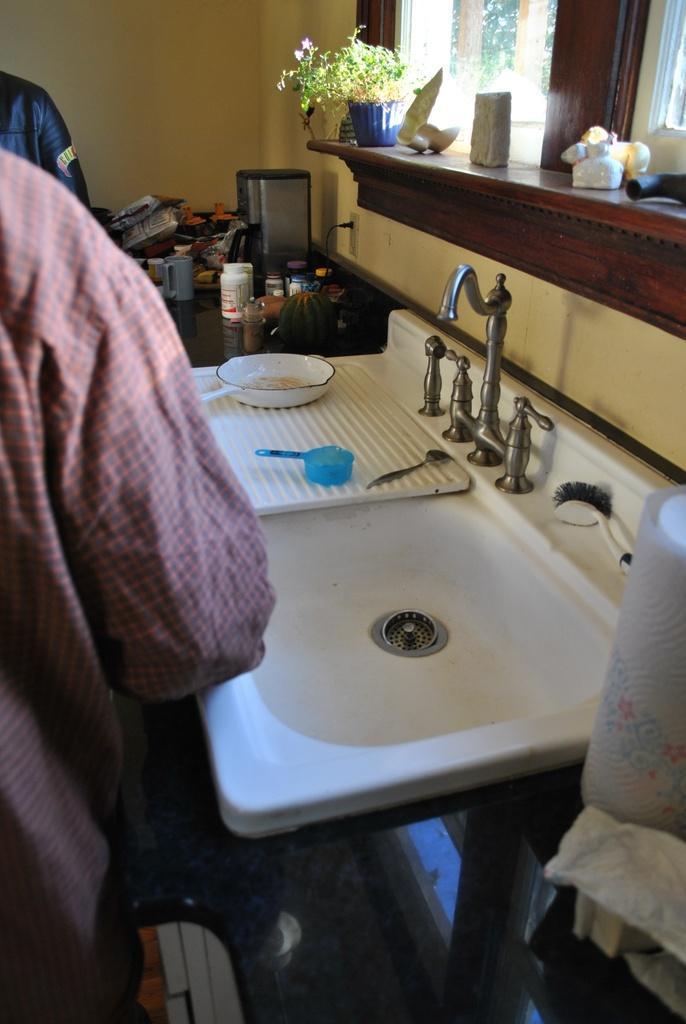Describe this image in one or two sentences. In this image there is a washing basin at right side of this image and there is one person standing at left side of this image and there are some objects are kept at top of this image. There are some objects at bottom right corner of this image as well. 